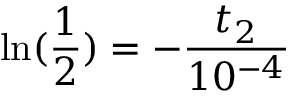<formula> <loc_0><loc_0><loc_500><loc_500>\ln ( \frac { 1 } { 2 } ) = - \frac { t _ { 2 } } { 1 0 ^ { - 4 } }</formula> 